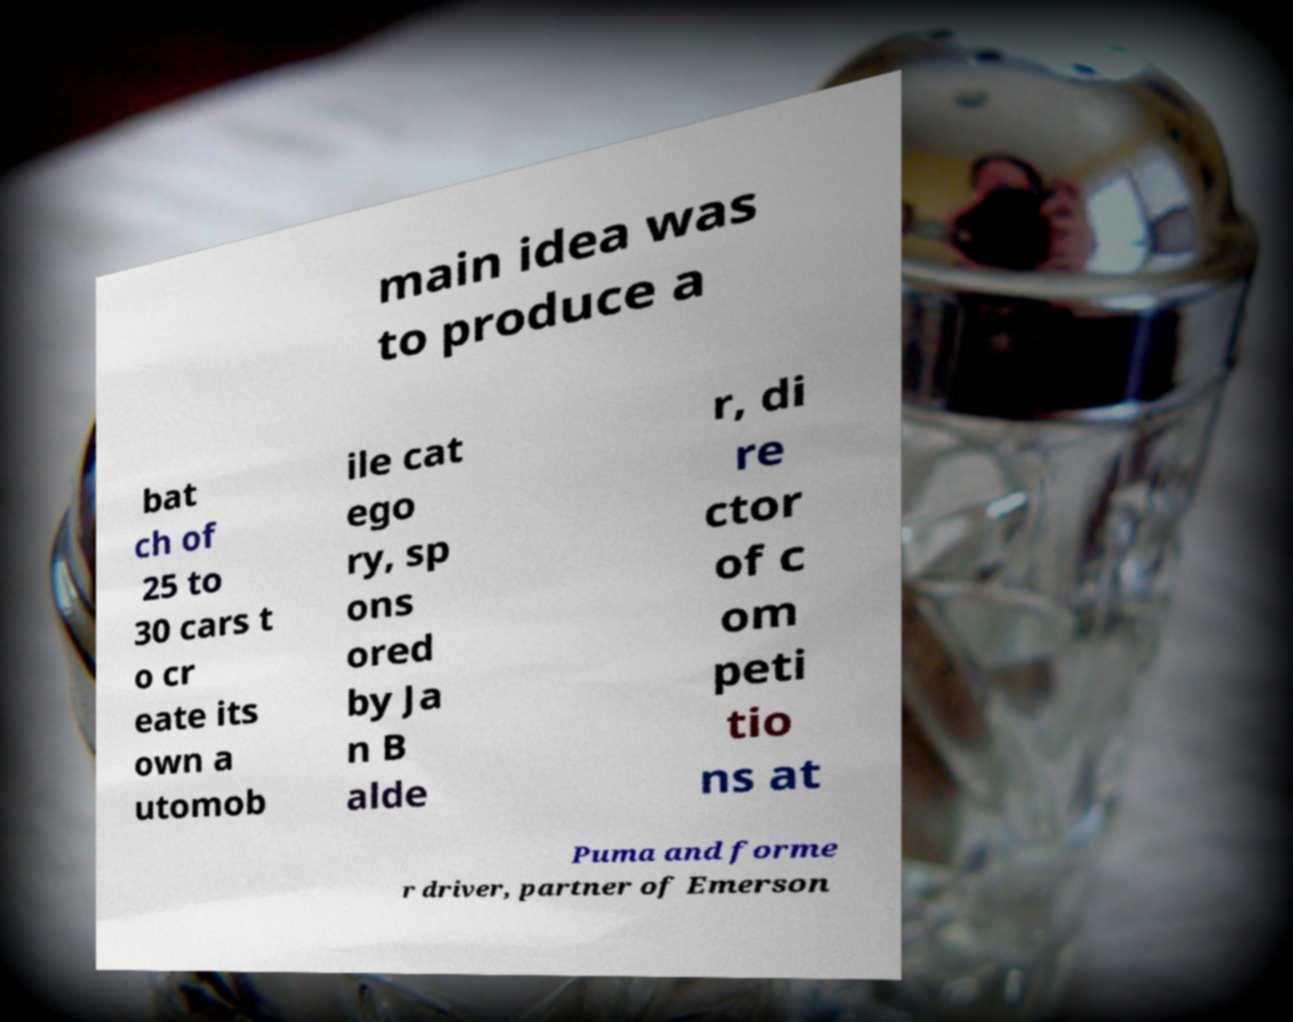Can you read and provide the text displayed in the image?This photo seems to have some interesting text. Can you extract and type it out for me? main idea was to produce a bat ch of 25 to 30 cars t o cr eate its own a utomob ile cat ego ry, sp ons ored by Ja n B alde r, di re ctor of c om peti tio ns at Puma and forme r driver, partner of Emerson 